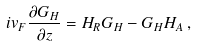<formula> <loc_0><loc_0><loc_500><loc_500>i v _ { F } \frac { \partial G _ { H } } { \partial z } = H _ { R } G _ { H } - G _ { H } H _ { A } \, ,</formula> 